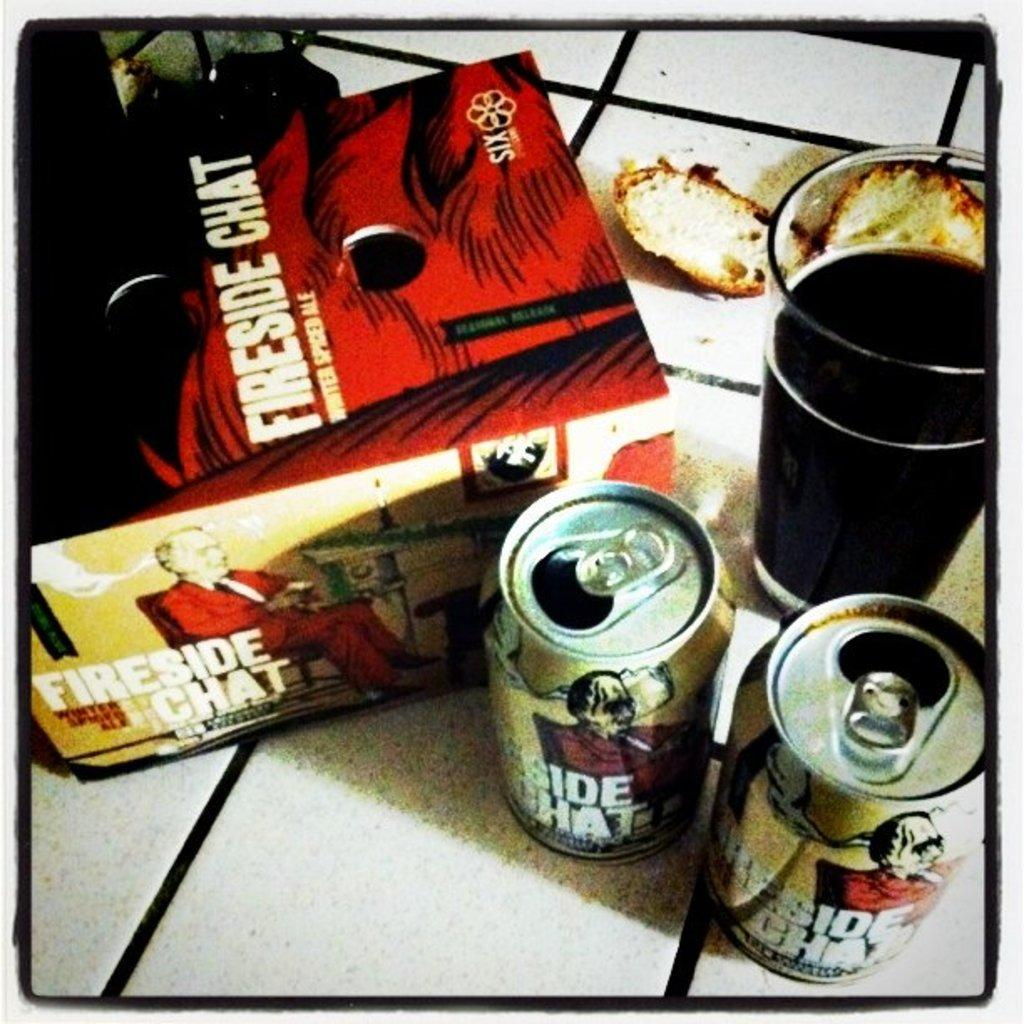<image>
Describe the image concisely. A twelve pack of Fireside Chat been with two open ones outside the 12 pack. 